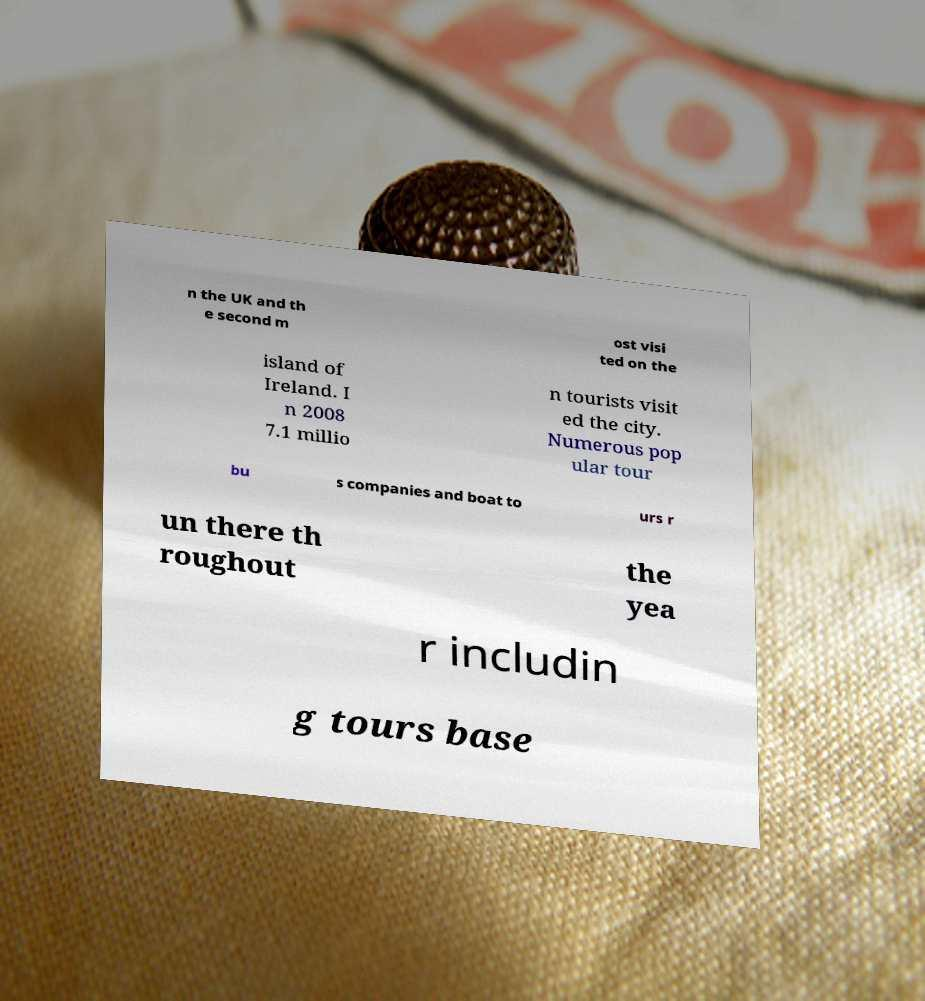Please read and relay the text visible in this image. What does it say? n the UK and th e second m ost visi ted on the island of Ireland. I n 2008 7.1 millio n tourists visit ed the city. Numerous pop ular tour bu s companies and boat to urs r un there th roughout the yea r includin g tours base 